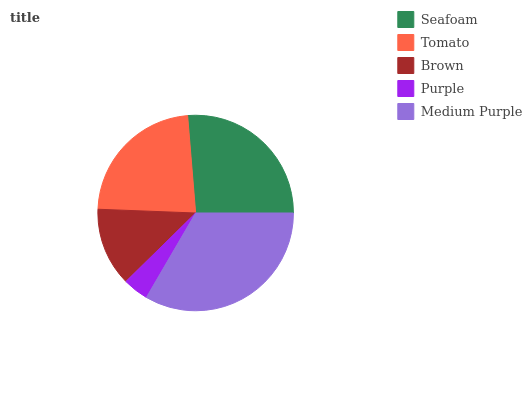Is Purple the minimum?
Answer yes or no. Yes. Is Medium Purple the maximum?
Answer yes or no. Yes. Is Tomato the minimum?
Answer yes or no. No. Is Tomato the maximum?
Answer yes or no. No. Is Seafoam greater than Tomato?
Answer yes or no. Yes. Is Tomato less than Seafoam?
Answer yes or no. Yes. Is Tomato greater than Seafoam?
Answer yes or no. No. Is Seafoam less than Tomato?
Answer yes or no. No. Is Tomato the high median?
Answer yes or no. Yes. Is Tomato the low median?
Answer yes or no. Yes. Is Medium Purple the high median?
Answer yes or no. No. Is Brown the low median?
Answer yes or no. No. 